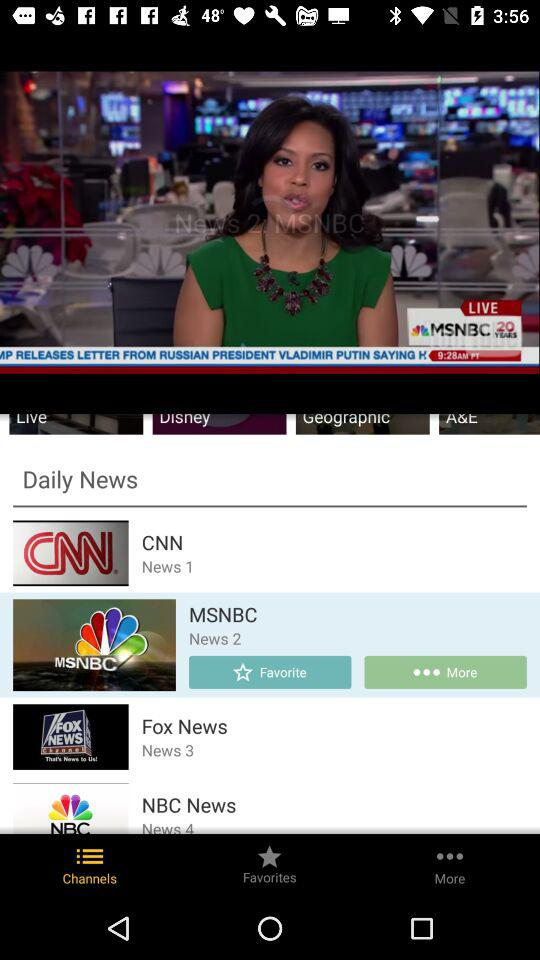How many live news channels are available?
Answer the question using a single word or phrase. 4 